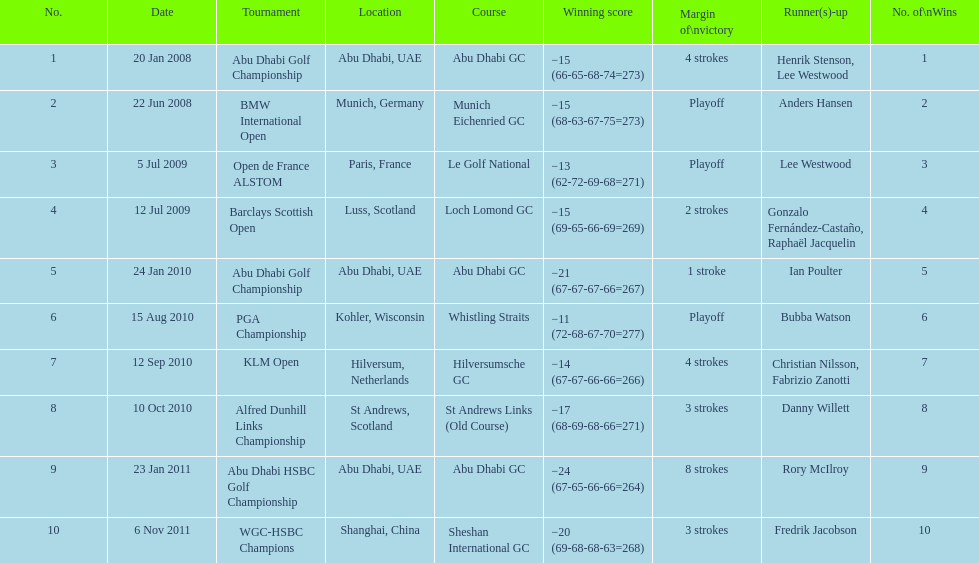How many more strokes were in the klm open than the barclays scottish open? 2 strokes. 